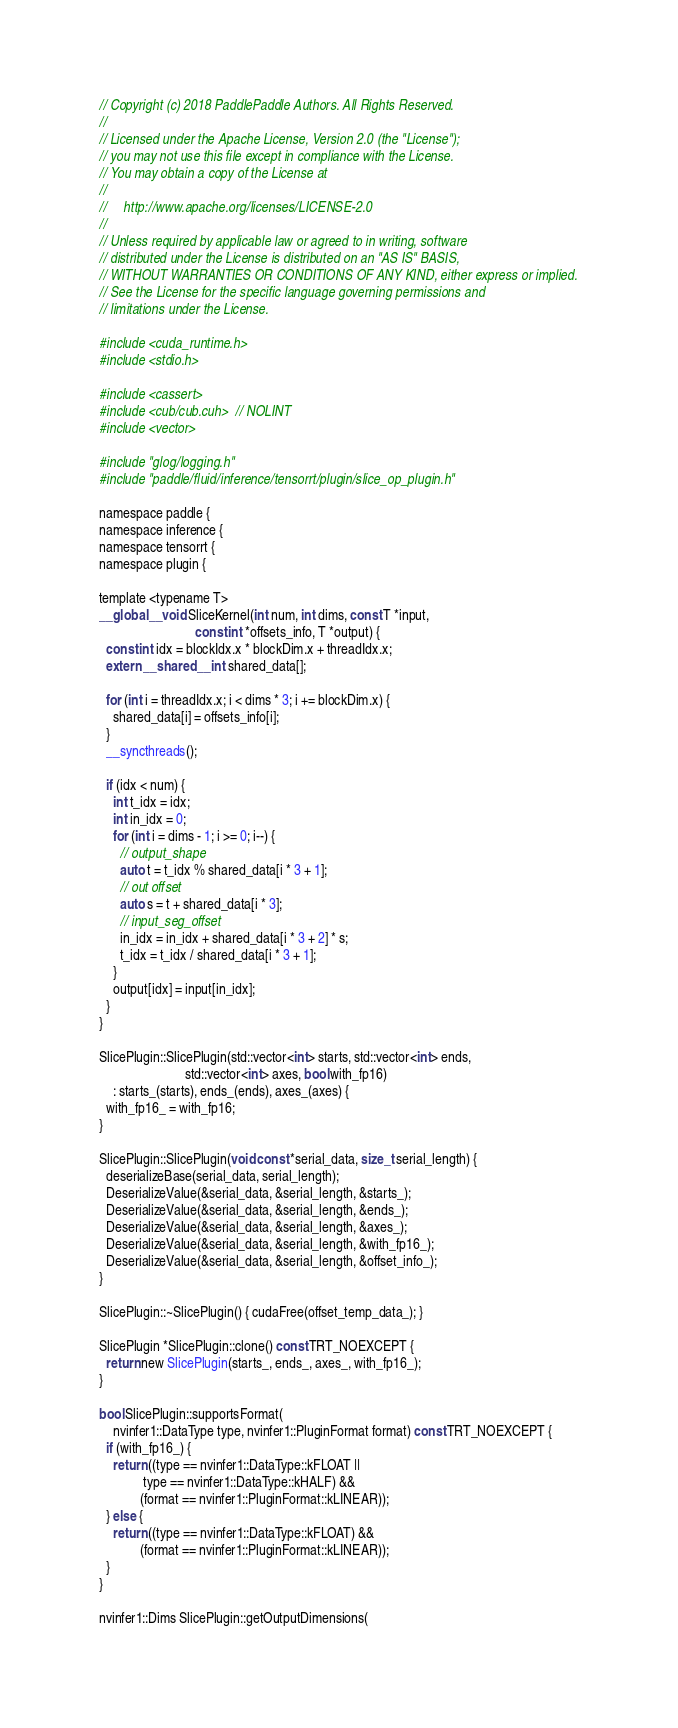Convert code to text. <code><loc_0><loc_0><loc_500><loc_500><_Cuda_>// Copyright (c) 2018 PaddlePaddle Authors. All Rights Reserved.
//
// Licensed under the Apache License, Version 2.0 (the "License");
// you may not use this file except in compliance with the License.
// You may obtain a copy of the License at
//
//     http://www.apache.org/licenses/LICENSE-2.0
//
// Unless required by applicable law or agreed to in writing, software
// distributed under the License is distributed on an "AS IS" BASIS,
// WITHOUT WARRANTIES OR CONDITIONS OF ANY KIND, either express or implied.
// See the License for the specific language governing permissions and
// limitations under the License.

#include <cuda_runtime.h>
#include <stdio.h>

#include <cassert>
#include <cub/cub.cuh>  // NOLINT
#include <vector>

#include "glog/logging.h"
#include "paddle/fluid/inference/tensorrt/plugin/slice_op_plugin.h"

namespace paddle {
namespace inference {
namespace tensorrt {
namespace plugin {

template <typename T>
__global__ void SliceKernel(int num, int dims, const T *input,
                            const int *offsets_info, T *output) {
  const int idx = blockIdx.x * blockDim.x + threadIdx.x;
  extern __shared__ int shared_data[];

  for (int i = threadIdx.x; i < dims * 3; i += blockDim.x) {
    shared_data[i] = offsets_info[i];
  }
  __syncthreads();

  if (idx < num) {
    int t_idx = idx;
    int in_idx = 0;
    for (int i = dims - 1; i >= 0; i--) {
      // output_shape
      auto t = t_idx % shared_data[i * 3 + 1];
      // out offset
      auto s = t + shared_data[i * 3];
      // input_seg_offset
      in_idx = in_idx + shared_data[i * 3 + 2] * s;
      t_idx = t_idx / shared_data[i * 3 + 1];
    }
    output[idx] = input[in_idx];
  }
}

SlicePlugin::SlicePlugin(std::vector<int> starts, std::vector<int> ends,
                         std::vector<int> axes, bool with_fp16)
    : starts_(starts), ends_(ends), axes_(axes) {
  with_fp16_ = with_fp16;
}

SlicePlugin::SlicePlugin(void const *serial_data, size_t serial_length) {
  deserializeBase(serial_data, serial_length);
  DeserializeValue(&serial_data, &serial_length, &starts_);
  DeserializeValue(&serial_data, &serial_length, &ends_);
  DeserializeValue(&serial_data, &serial_length, &axes_);
  DeserializeValue(&serial_data, &serial_length, &with_fp16_);
  DeserializeValue(&serial_data, &serial_length, &offset_info_);
}

SlicePlugin::~SlicePlugin() { cudaFree(offset_temp_data_); }

SlicePlugin *SlicePlugin::clone() const TRT_NOEXCEPT {
  return new SlicePlugin(starts_, ends_, axes_, with_fp16_);
}

bool SlicePlugin::supportsFormat(
    nvinfer1::DataType type, nvinfer1::PluginFormat format) const TRT_NOEXCEPT {
  if (with_fp16_) {
    return ((type == nvinfer1::DataType::kFLOAT ||
             type == nvinfer1::DataType::kHALF) &&
            (format == nvinfer1::PluginFormat::kLINEAR));
  } else {
    return ((type == nvinfer1::DataType::kFLOAT) &&
            (format == nvinfer1::PluginFormat::kLINEAR));
  }
}

nvinfer1::Dims SlicePlugin::getOutputDimensions(</code> 